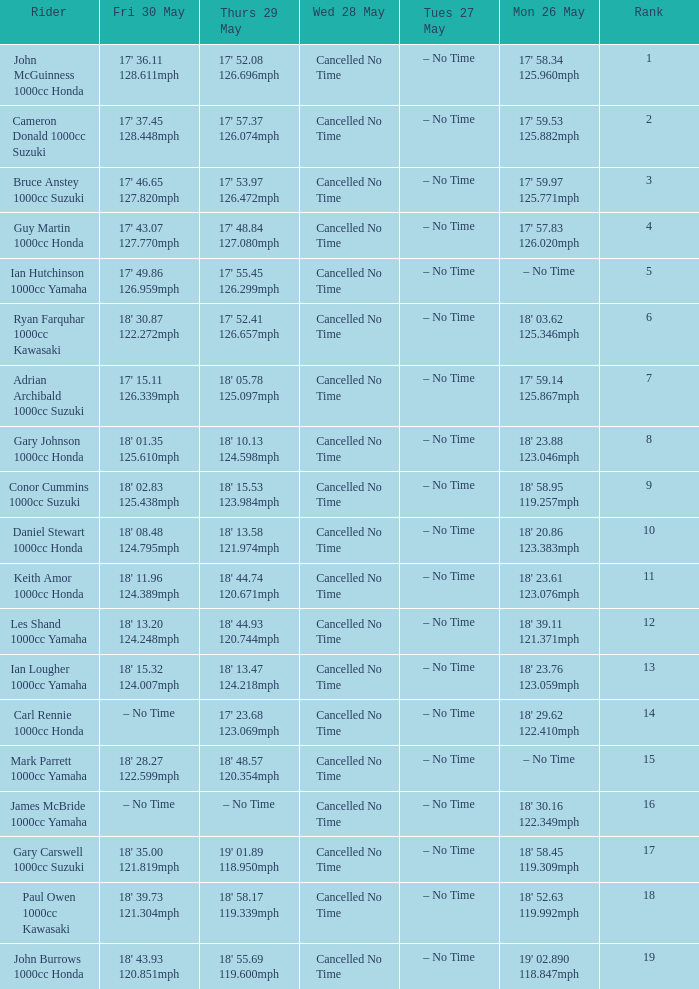What tims is wed may 28 and mon may 26 is 17' 58.34 125.960mph? Cancelled No Time. 